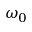Convert formula to latex. <formula><loc_0><loc_0><loc_500><loc_500>\omega _ { 0 }</formula> 